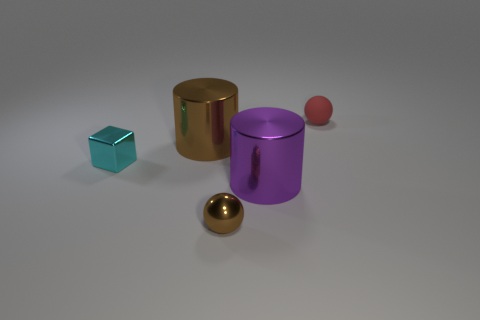Add 2 tiny red matte balls. How many objects exist? 7 Subtract all cylinders. How many objects are left? 3 Add 4 large brown cylinders. How many large brown cylinders are left? 5 Add 2 purple metallic cylinders. How many purple metallic cylinders exist? 3 Subtract 0 red cylinders. How many objects are left? 5 Subtract all red objects. Subtract all cylinders. How many objects are left? 2 